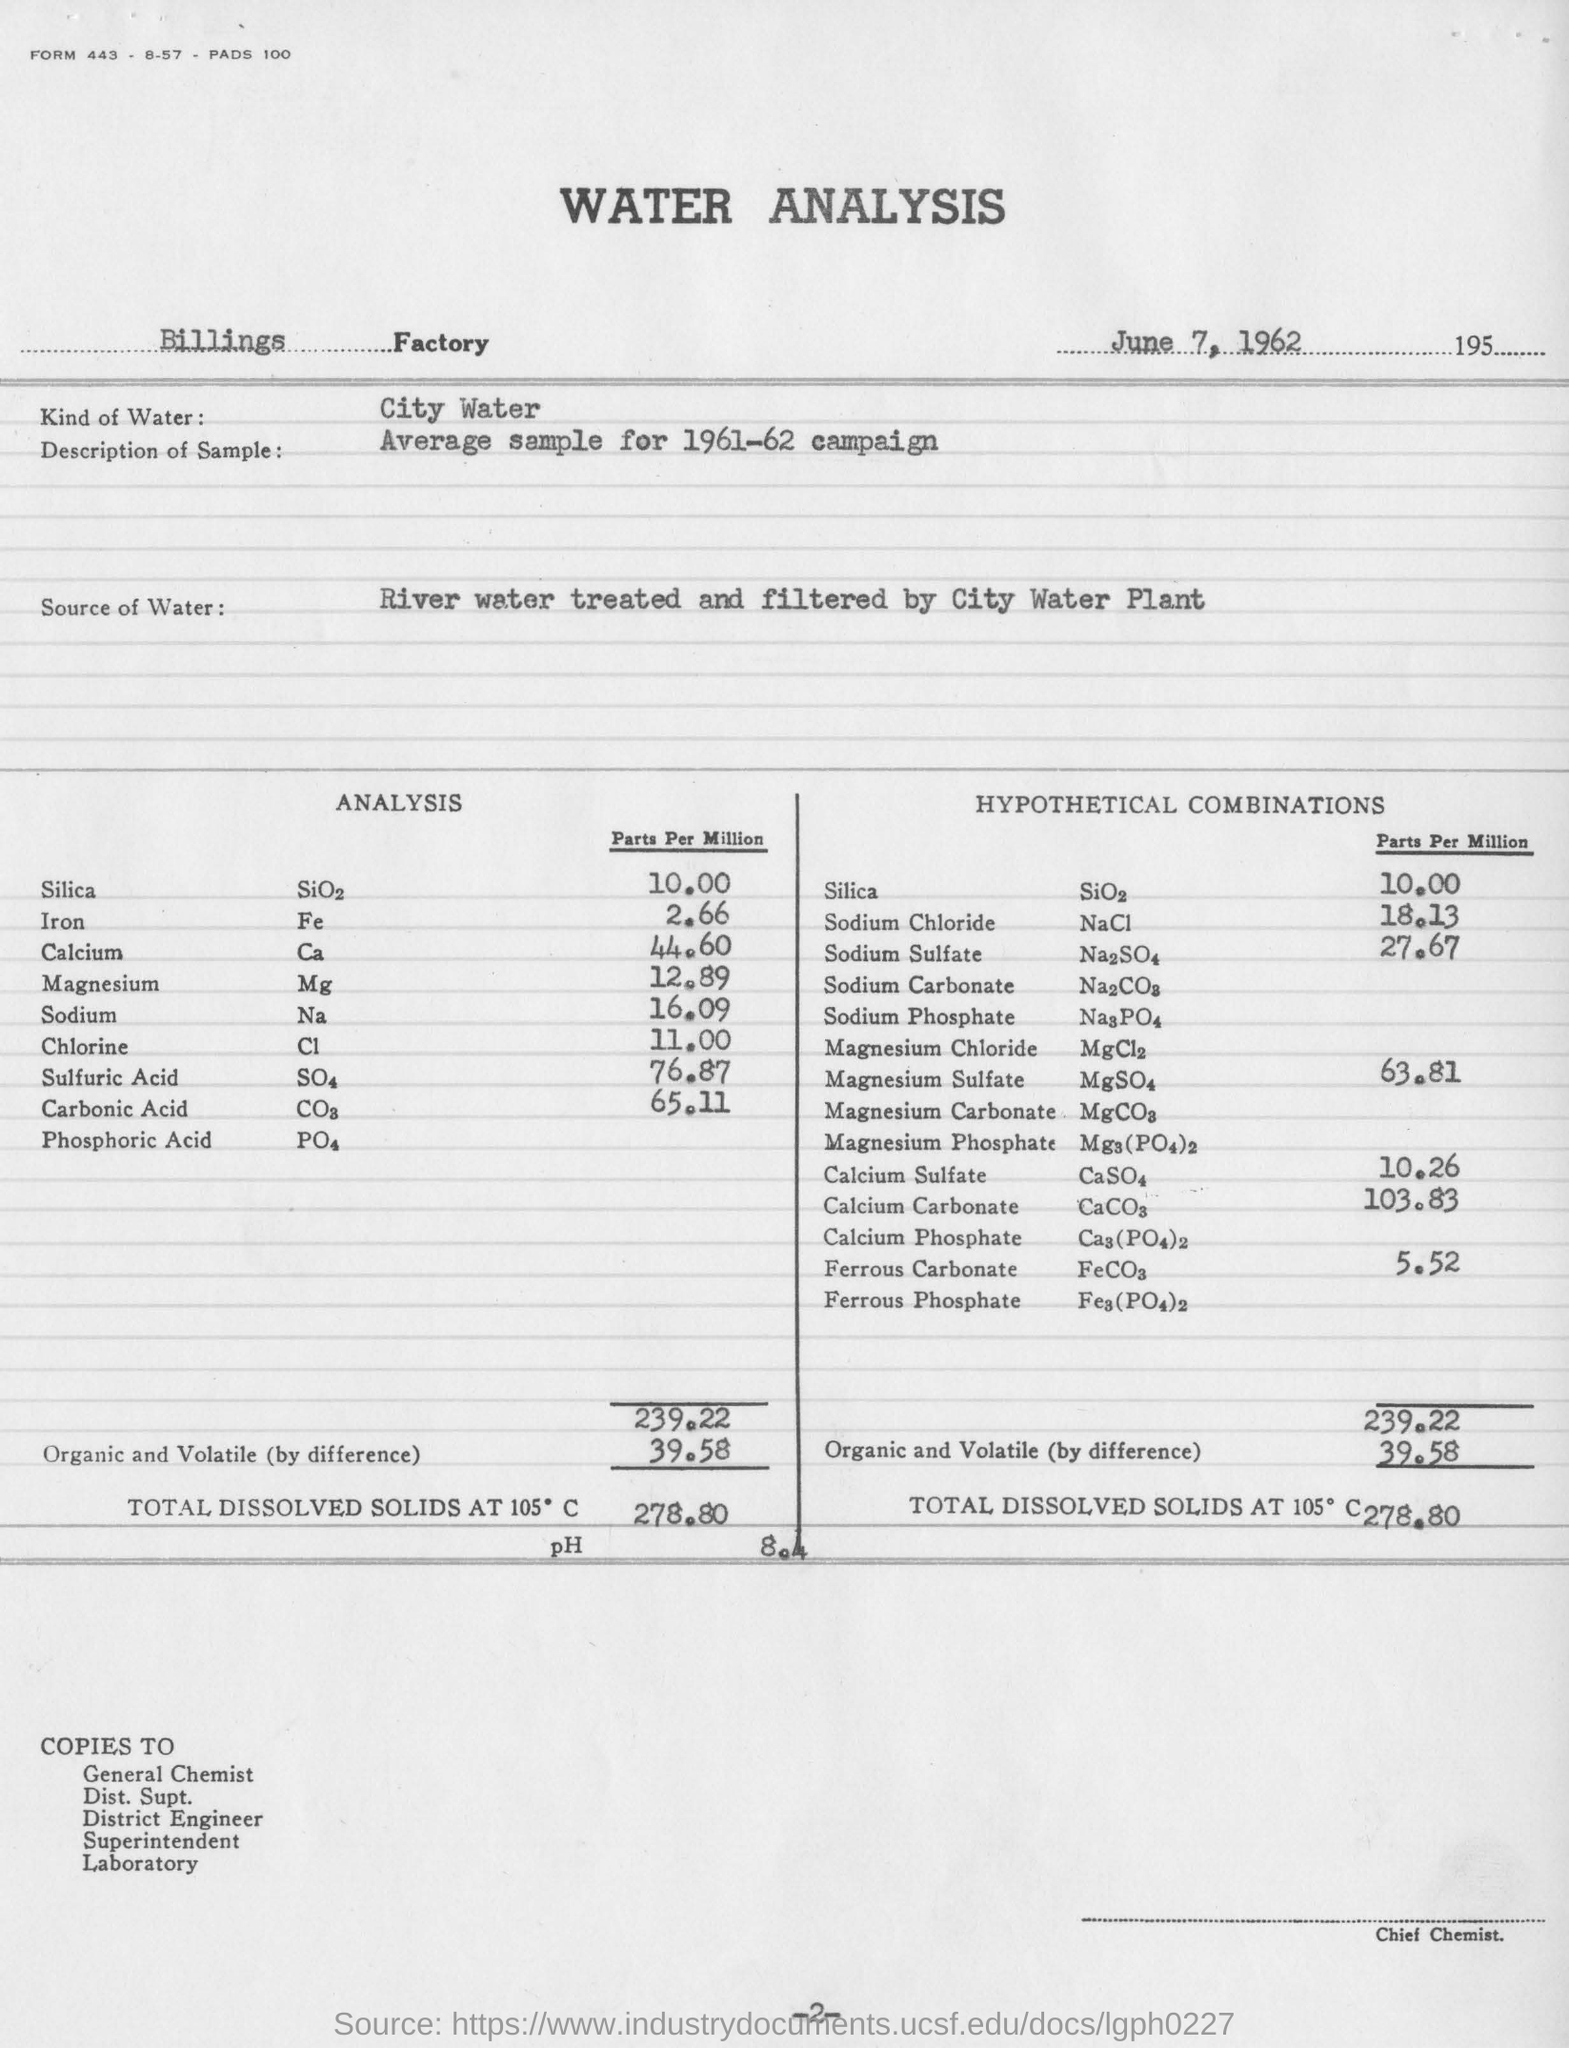List a handful of essential elements in this visual. The Billings Factory is mentioned. The type of water used in the analysis was city water. The date of analysis is June 7, 1962. 